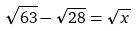Convert formula to latex. <formula><loc_0><loc_0><loc_500><loc_500>\sqrt { 6 3 } - \sqrt { 2 8 } = \sqrt { x }</formula> 